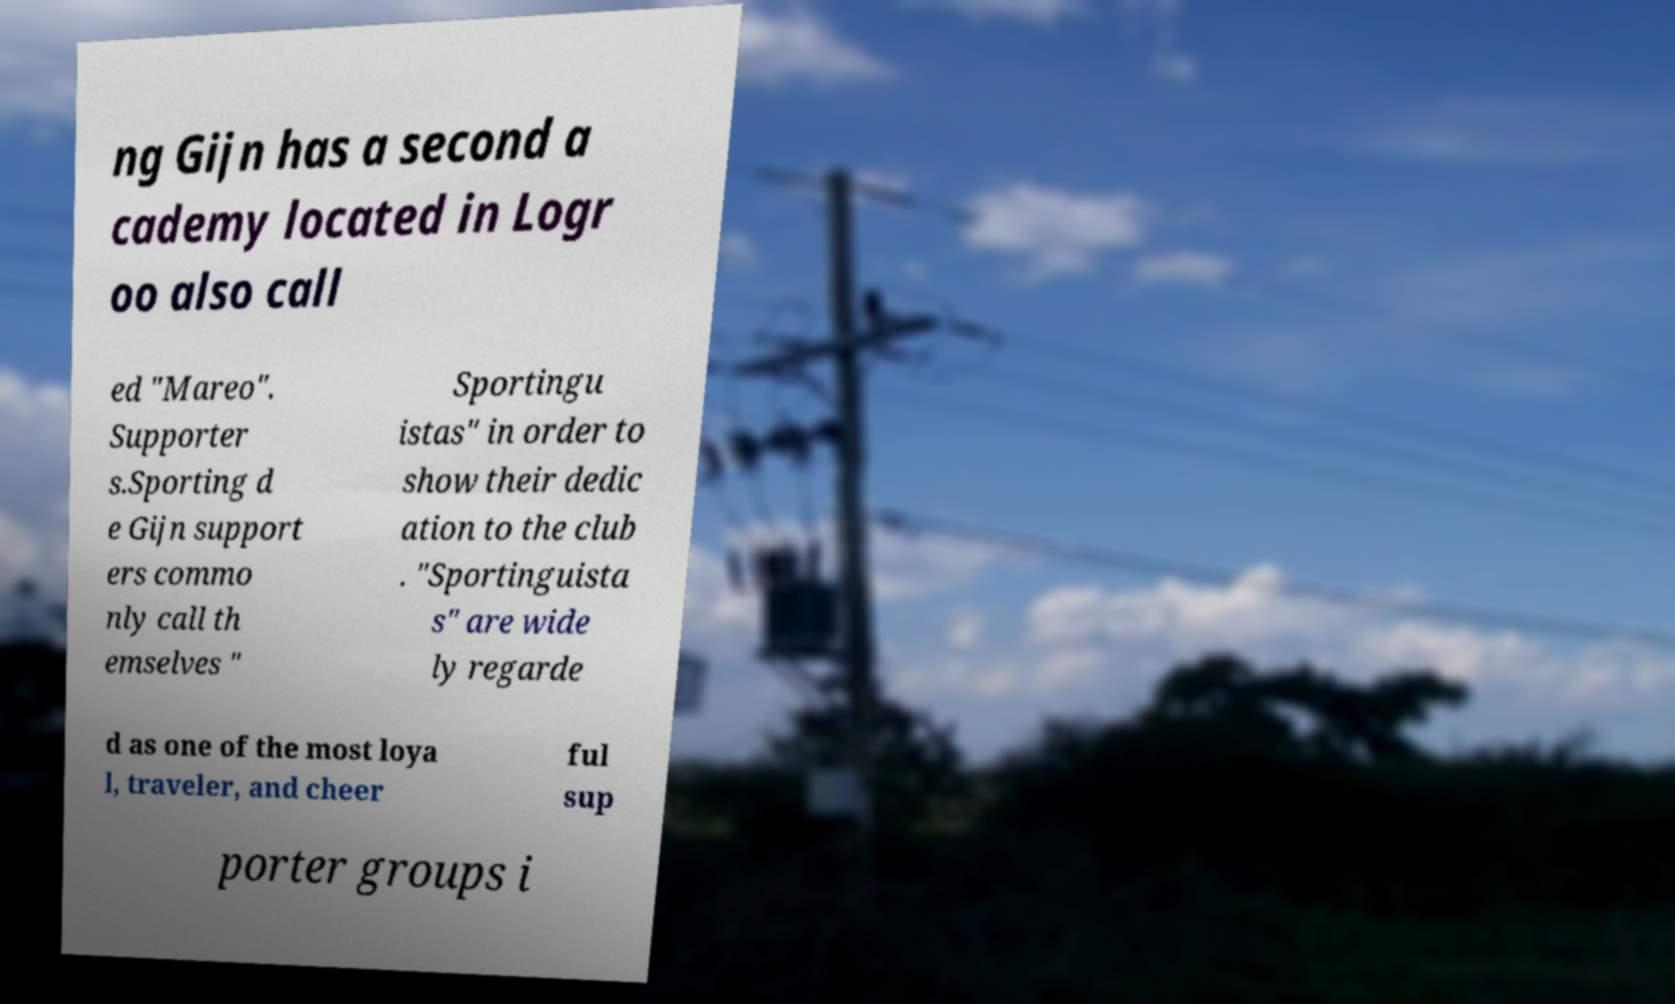Could you assist in decoding the text presented in this image and type it out clearly? ng Gijn has a second a cademy located in Logr oo also call ed "Mareo". Supporter s.Sporting d e Gijn support ers commo nly call th emselves " Sportingu istas" in order to show their dedic ation to the club . "Sportinguista s" are wide ly regarde d as one of the most loya l, traveler, and cheer ful sup porter groups i 